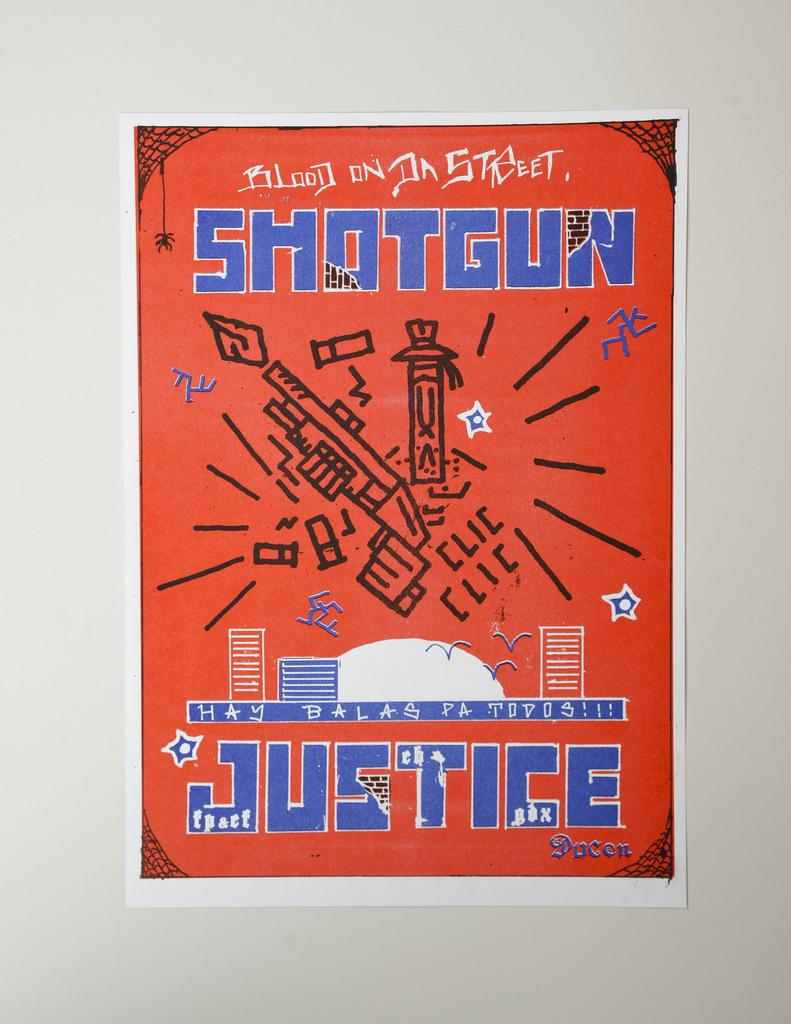<image>
Write a terse but informative summary of the picture. an ad that says shotgun justice on it 